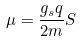Convert formula to latex. <formula><loc_0><loc_0><loc_500><loc_500>\mu = \frac { g _ { s } q } { 2 m } S</formula> 